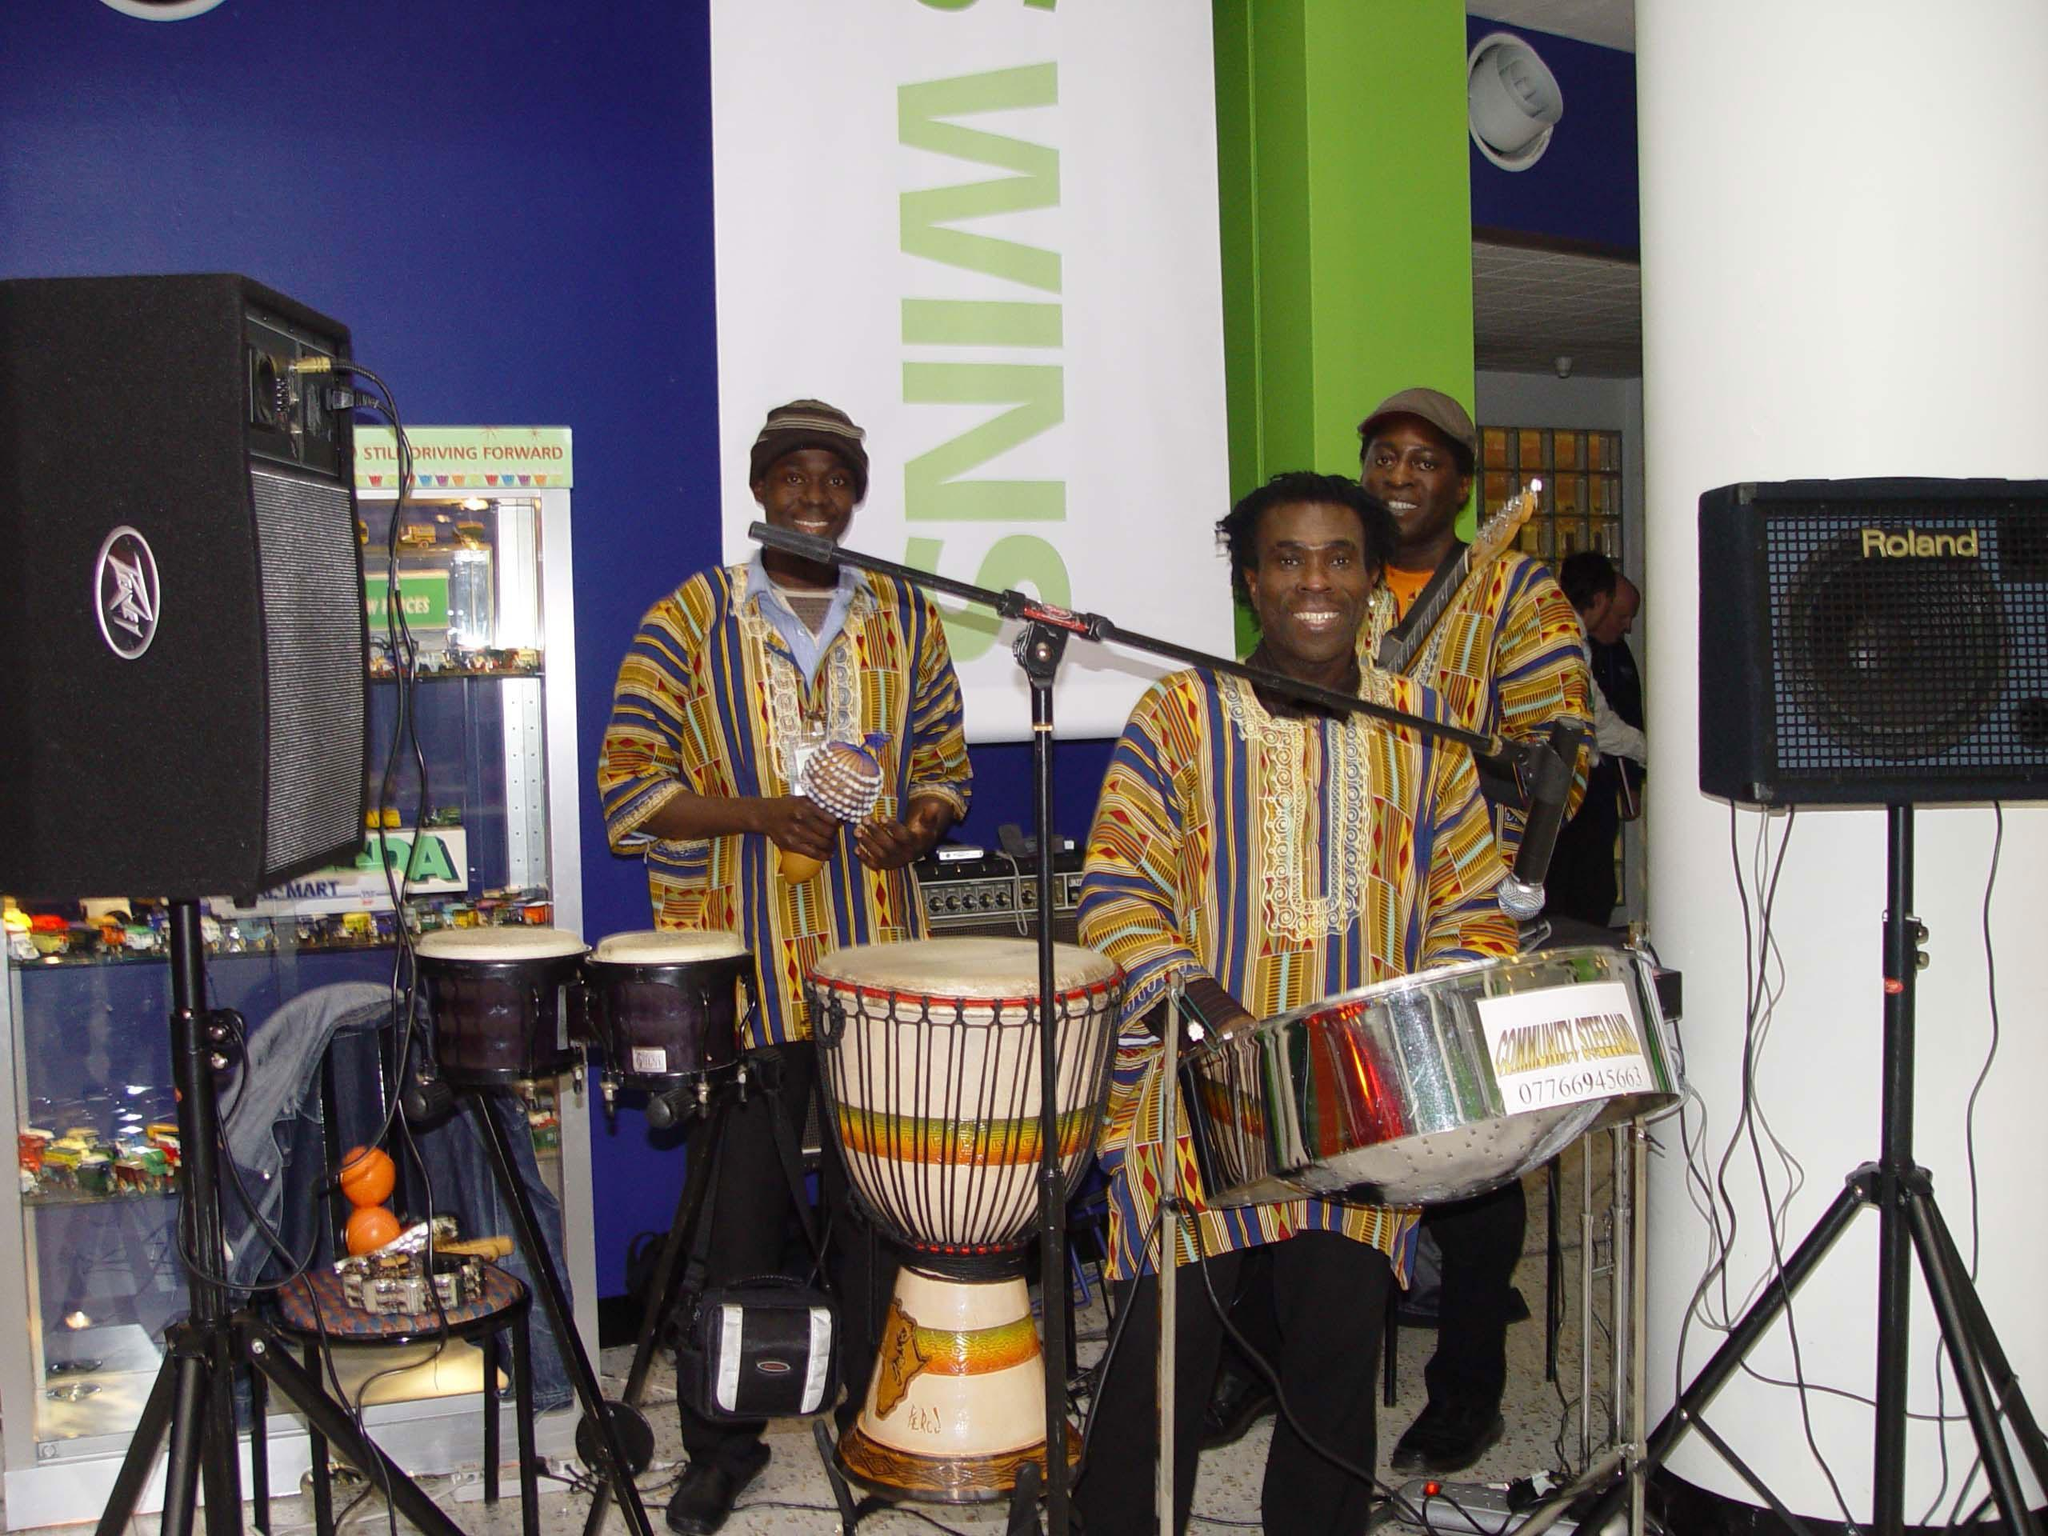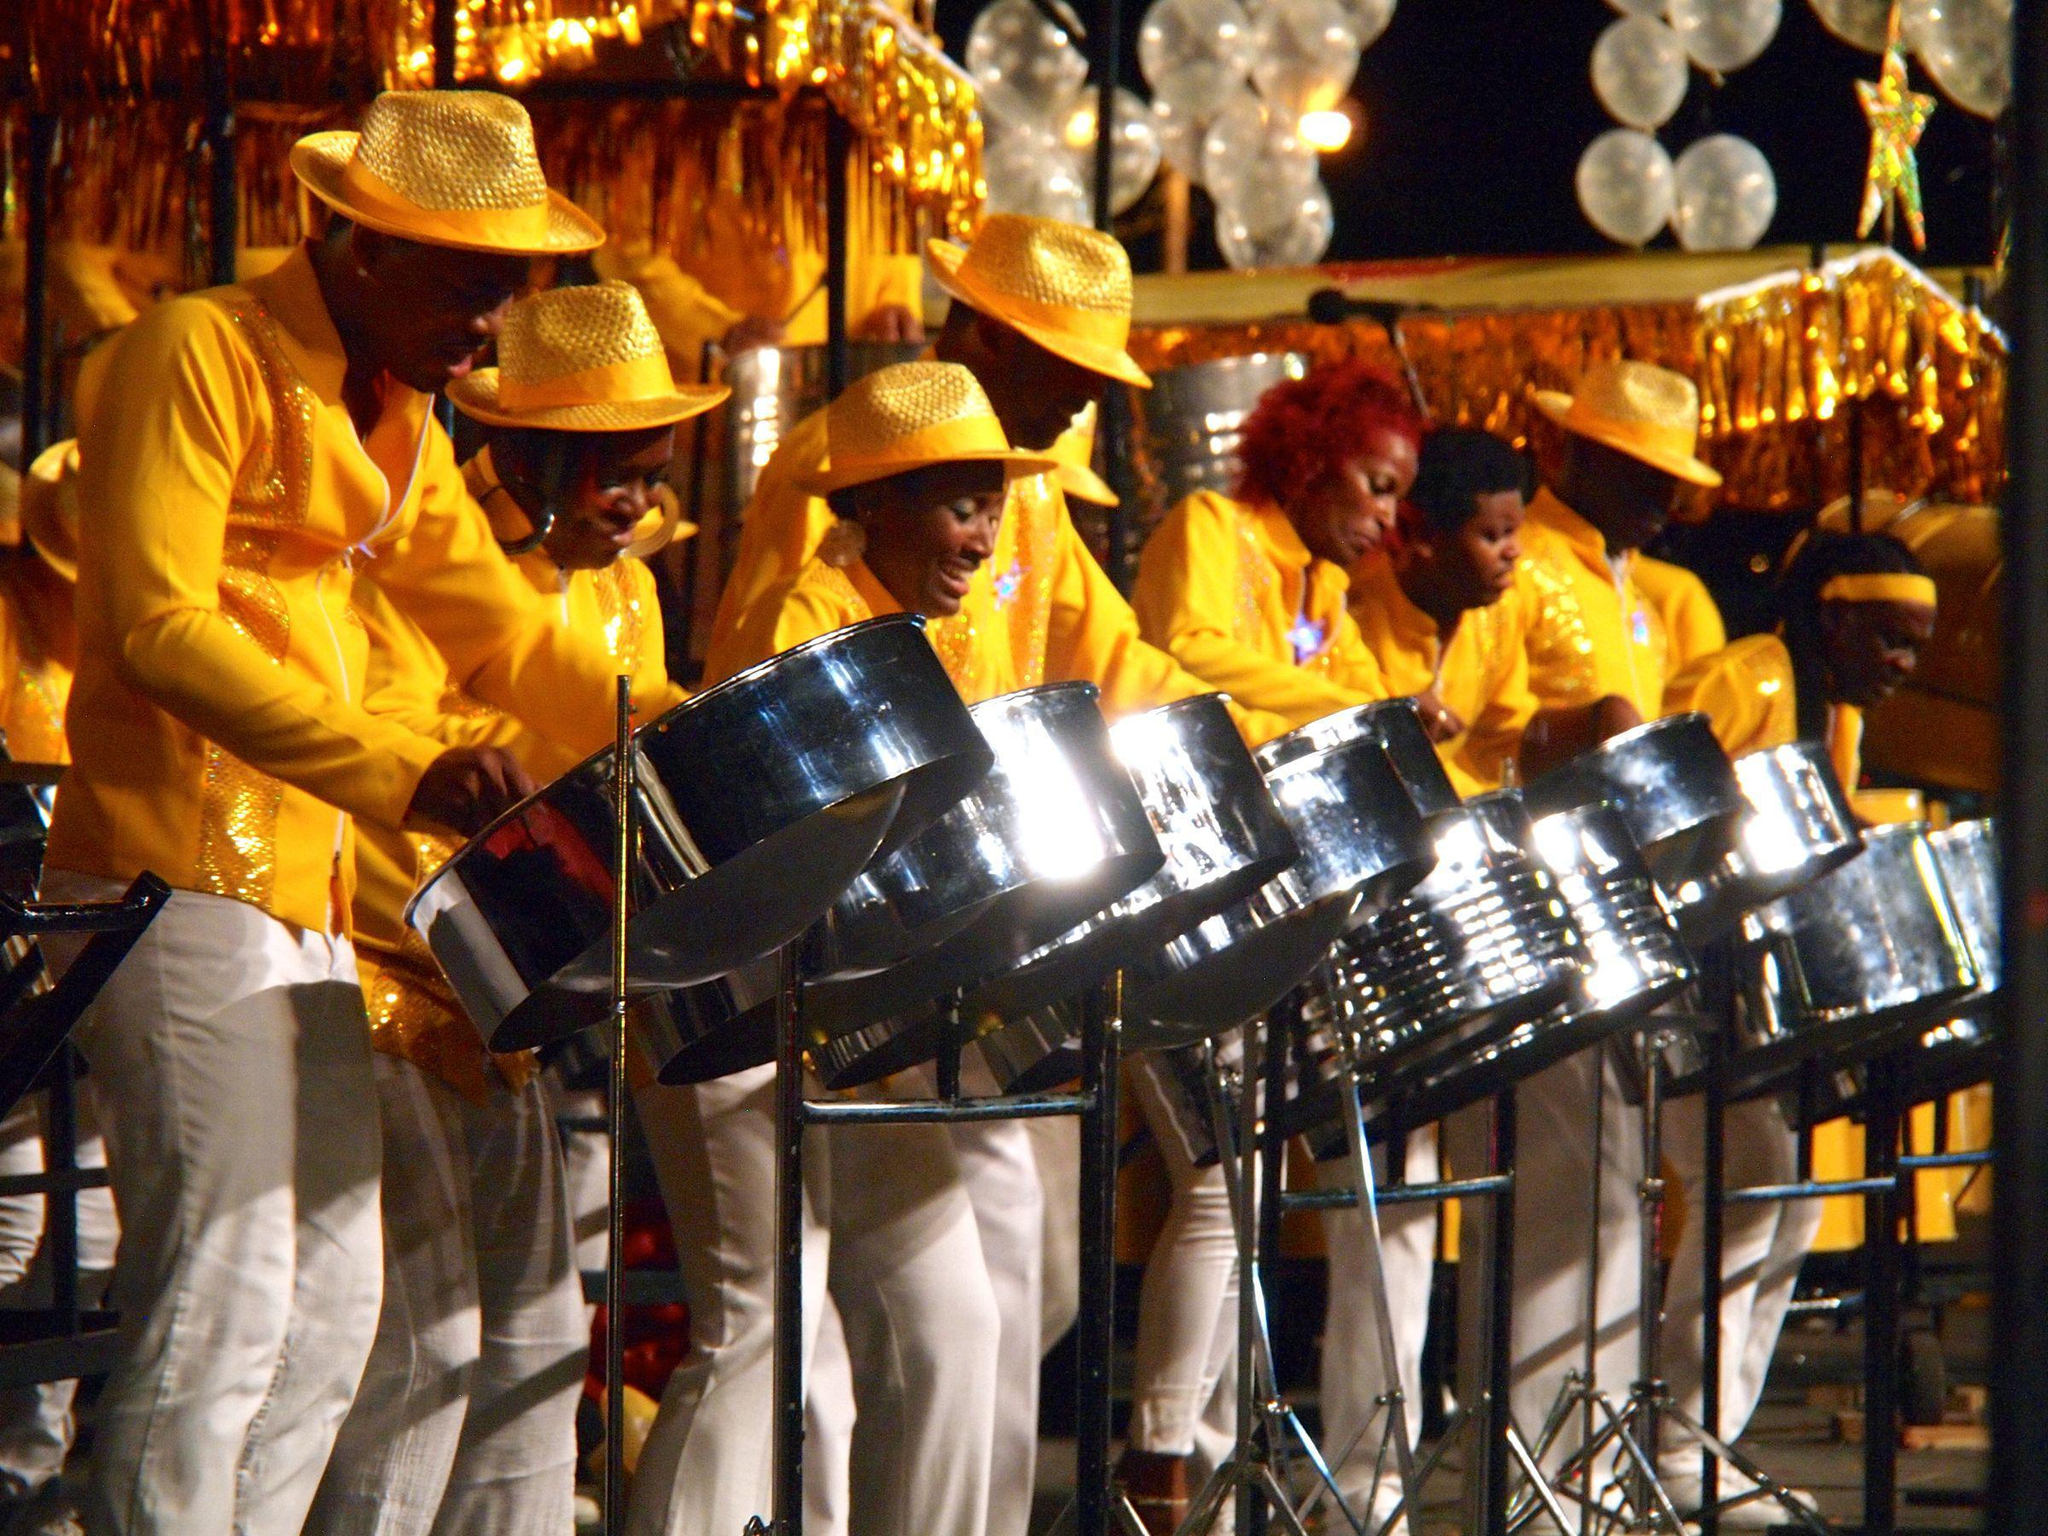The first image is the image on the left, the second image is the image on the right. Given the left and right images, does the statement "In one image, every musician is wearing a hat." hold true? Answer yes or no. No. The first image is the image on the left, the second image is the image on the right. Considering the images on both sides, is "The right image shows a line of standing drummers in shiny fedora hats, with silver drums on stands in front of them." valid? Answer yes or no. Yes. 